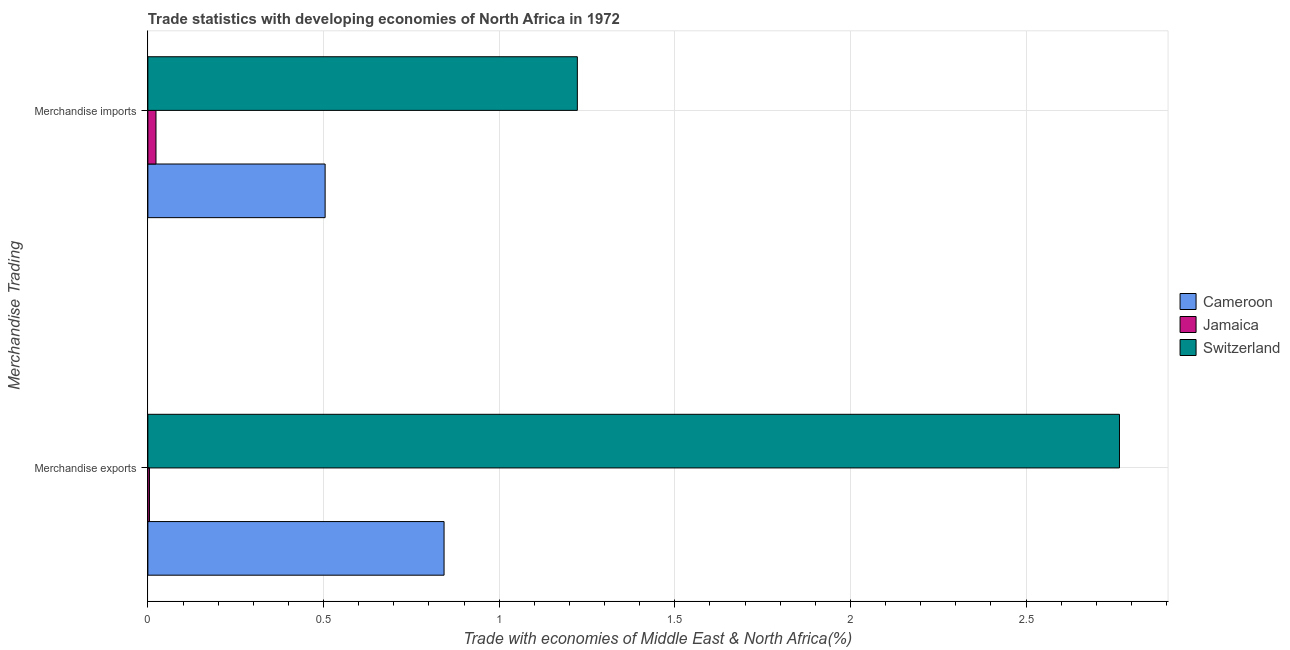How many groups of bars are there?
Make the answer very short. 2. Are the number of bars per tick equal to the number of legend labels?
Your answer should be very brief. Yes. What is the merchandise exports in Jamaica?
Make the answer very short. 0. Across all countries, what is the maximum merchandise imports?
Ensure brevity in your answer.  1.22. Across all countries, what is the minimum merchandise imports?
Provide a short and direct response. 0.02. In which country was the merchandise imports maximum?
Your answer should be compact. Switzerland. In which country was the merchandise exports minimum?
Your response must be concise. Jamaica. What is the total merchandise imports in the graph?
Offer a very short reply. 1.75. What is the difference between the merchandise imports in Switzerland and that in Jamaica?
Keep it short and to the point. 1.2. What is the difference between the merchandise imports in Cameroon and the merchandise exports in Jamaica?
Give a very brief answer. 0.5. What is the average merchandise exports per country?
Your response must be concise. 1.2. What is the difference between the merchandise exports and merchandise imports in Cameroon?
Provide a succinct answer. 0.34. What is the ratio of the merchandise exports in Switzerland to that in Jamaica?
Your answer should be compact. 609.61. Is the merchandise exports in Jamaica less than that in Switzerland?
Your answer should be compact. Yes. In how many countries, is the merchandise exports greater than the average merchandise exports taken over all countries?
Give a very brief answer. 1. What does the 2nd bar from the top in Merchandise imports represents?
Keep it short and to the point. Jamaica. What does the 3rd bar from the bottom in Merchandise exports represents?
Make the answer very short. Switzerland. Are all the bars in the graph horizontal?
Ensure brevity in your answer.  Yes. How many countries are there in the graph?
Keep it short and to the point. 3. What is the difference between two consecutive major ticks on the X-axis?
Ensure brevity in your answer.  0.5. Where does the legend appear in the graph?
Offer a terse response. Center right. How many legend labels are there?
Offer a terse response. 3. How are the legend labels stacked?
Make the answer very short. Vertical. What is the title of the graph?
Provide a succinct answer. Trade statistics with developing economies of North Africa in 1972. What is the label or title of the X-axis?
Make the answer very short. Trade with economies of Middle East & North Africa(%). What is the label or title of the Y-axis?
Your answer should be very brief. Merchandise Trading. What is the Trade with economies of Middle East & North Africa(%) of Cameroon in Merchandise exports?
Offer a terse response. 0.84. What is the Trade with economies of Middle East & North Africa(%) of Jamaica in Merchandise exports?
Give a very brief answer. 0. What is the Trade with economies of Middle East & North Africa(%) in Switzerland in Merchandise exports?
Offer a very short reply. 2.77. What is the Trade with economies of Middle East & North Africa(%) in Cameroon in Merchandise imports?
Your answer should be compact. 0.5. What is the Trade with economies of Middle East & North Africa(%) of Jamaica in Merchandise imports?
Provide a succinct answer. 0.02. What is the Trade with economies of Middle East & North Africa(%) of Switzerland in Merchandise imports?
Provide a short and direct response. 1.22. Across all Merchandise Trading, what is the maximum Trade with economies of Middle East & North Africa(%) in Cameroon?
Provide a succinct answer. 0.84. Across all Merchandise Trading, what is the maximum Trade with economies of Middle East & North Africa(%) in Jamaica?
Your answer should be very brief. 0.02. Across all Merchandise Trading, what is the maximum Trade with economies of Middle East & North Africa(%) of Switzerland?
Your answer should be compact. 2.77. Across all Merchandise Trading, what is the minimum Trade with economies of Middle East & North Africa(%) of Cameroon?
Give a very brief answer. 0.5. Across all Merchandise Trading, what is the minimum Trade with economies of Middle East & North Africa(%) of Jamaica?
Provide a succinct answer. 0. Across all Merchandise Trading, what is the minimum Trade with economies of Middle East & North Africa(%) of Switzerland?
Make the answer very short. 1.22. What is the total Trade with economies of Middle East & North Africa(%) of Cameroon in the graph?
Provide a short and direct response. 1.35. What is the total Trade with economies of Middle East & North Africa(%) in Jamaica in the graph?
Offer a terse response. 0.03. What is the total Trade with economies of Middle East & North Africa(%) of Switzerland in the graph?
Keep it short and to the point. 3.99. What is the difference between the Trade with economies of Middle East & North Africa(%) in Cameroon in Merchandise exports and that in Merchandise imports?
Ensure brevity in your answer.  0.34. What is the difference between the Trade with economies of Middle East & North Africa(%) of Jamaica in Merchandise exports and that in Merchandise imports?
Make the answer very short. -0.02. What is the difference between the Trade with economies of Middle East & North Africa(%) of Switzerland in Merchandise exports and that in Merchandise imports?
Keep it short and to the point. 1.54. What is the difference between the Trade with economies of Middle East & North Africa(%) in Cameroon in Merchandise exports and the Trade with economies of Middle East & North Africa(%) in Jamaica in Merchandise imports?
Your answer should be very brief. 0.82. What is the difference between the Trade with economies of Middle East & North Africa(%) in Cameroon in Merchandise exports and the Trade with economies of Middle East & North Africa(%) in Switzerland in Merchandise imports?
Your answer should be compact. -0.38. What is the difference between the Trade with economies of Middle East & North Africa(%) in Jamaica in Merchandise exports and the Trade with economies of Middle East & North Africa(%) in Switzerland in Merchandise imports?
Keep it short and to the point. -1.22. What is the average Trade with economies of Middle East & North Africa(%) in Cameroon per Merchandise Trading?
Your answer should be very brief. 0.67. What is the average Trade with economies of Middle East & North Africa(%) in Jamaica per Merchandise Trading?
Your answer should be compact. 0.01. What is the average Trade with economies of Middle East & North Africa(%) in Switzerland per Merchandise Trading?
Provide a short and direct response. 1.99. What is the difference between the Trade with economies of Middle East & North Africa(%) of Cameroon and Trade with economies of Middle East & North Africa(%) of Jamaica in Merchandise exports?
Your response must be concise. 0.84. What is the difference between the Trade with economies of Middle East & North Africa(%) in Cameroon and Trade with economies of Middle East & North Africa(%) in Switzerland in Merchandise exports?
Give a very brief answer. -1.92. What is the difference between the Trade with economies of Middle East & North Africa(%) in Jamaica and Trade with economies of Middle East & North Africa(%) in Switzerland in Merchandise exports?
Ensure brevity in your answer.  -2.76. What is the difference between the Trade with economies of Middle East & North Africa(%) in Cameroon and Trade with economies of Middle East & North Africa(%) in Jamaica in Merchandise imports?
Your response must be concise. 0.48. What is the difference between the Trade with economies of Middle East & North Africa(%) in Cameroon and Trade with economies of Middle East & North Africa(%) in Switzerland in Merchandise imports?
Your answer should be compact. -0.72. What is the difference between the Trade with economies of Middle East & North Africa(%) of Jamaica and Trade with economies of Middle East & North Africa(%) of Switzerland in Merchandise imports?
Offer a terse response. -1.2. What is the ratio of the Trade with economies of Middle East & North Africa(%) in Cameroon in Merchandise exports to that in Merchandise imports?
Your answer should be compact. 1.67. What is the ratio of the Trade with economies of Middle East & North Africa(%) in Jamaica in Merchandise exports to that in Merchandise imports?
Offer a terse response. 0.2. What is the ratio of the Trade with economies of Middle East & North Africa(%) in Switzerland in Merchandise exports to that in Merchandise imports?
Ensure brevity in your answer.  2.26. What is the difference between the highest and the second highest Trade with economies of Middle East & North Africa(%) of Cameroon?
Give a very brief answer. 0.34. What is the difference between the highest and the second highest Trade with economies of Middle East & North Africa(%) of Jamaica?
Your answer should be compact. 0.02. What is the difference between the highest and the second highest Trade with economies of Middle East & North Africa(%) in Switzerland?
Keep it short and to the point. 1.54. What is the difference between the highest and the lowest Trade with economies of Middle East & North Africa(%) in Cameroon?
Give a very brief answer. 0.34. What is the difference between the highest and the lowest Trade with economies of Middle East & North Africa(%) in Jamaica?
Your response must be concise. 0.02. What is the difference between the highest and the lowest Trade with economies of Middle East & North Africa(%) of Switzerland?
Provide a succinct answer. 1.54. 